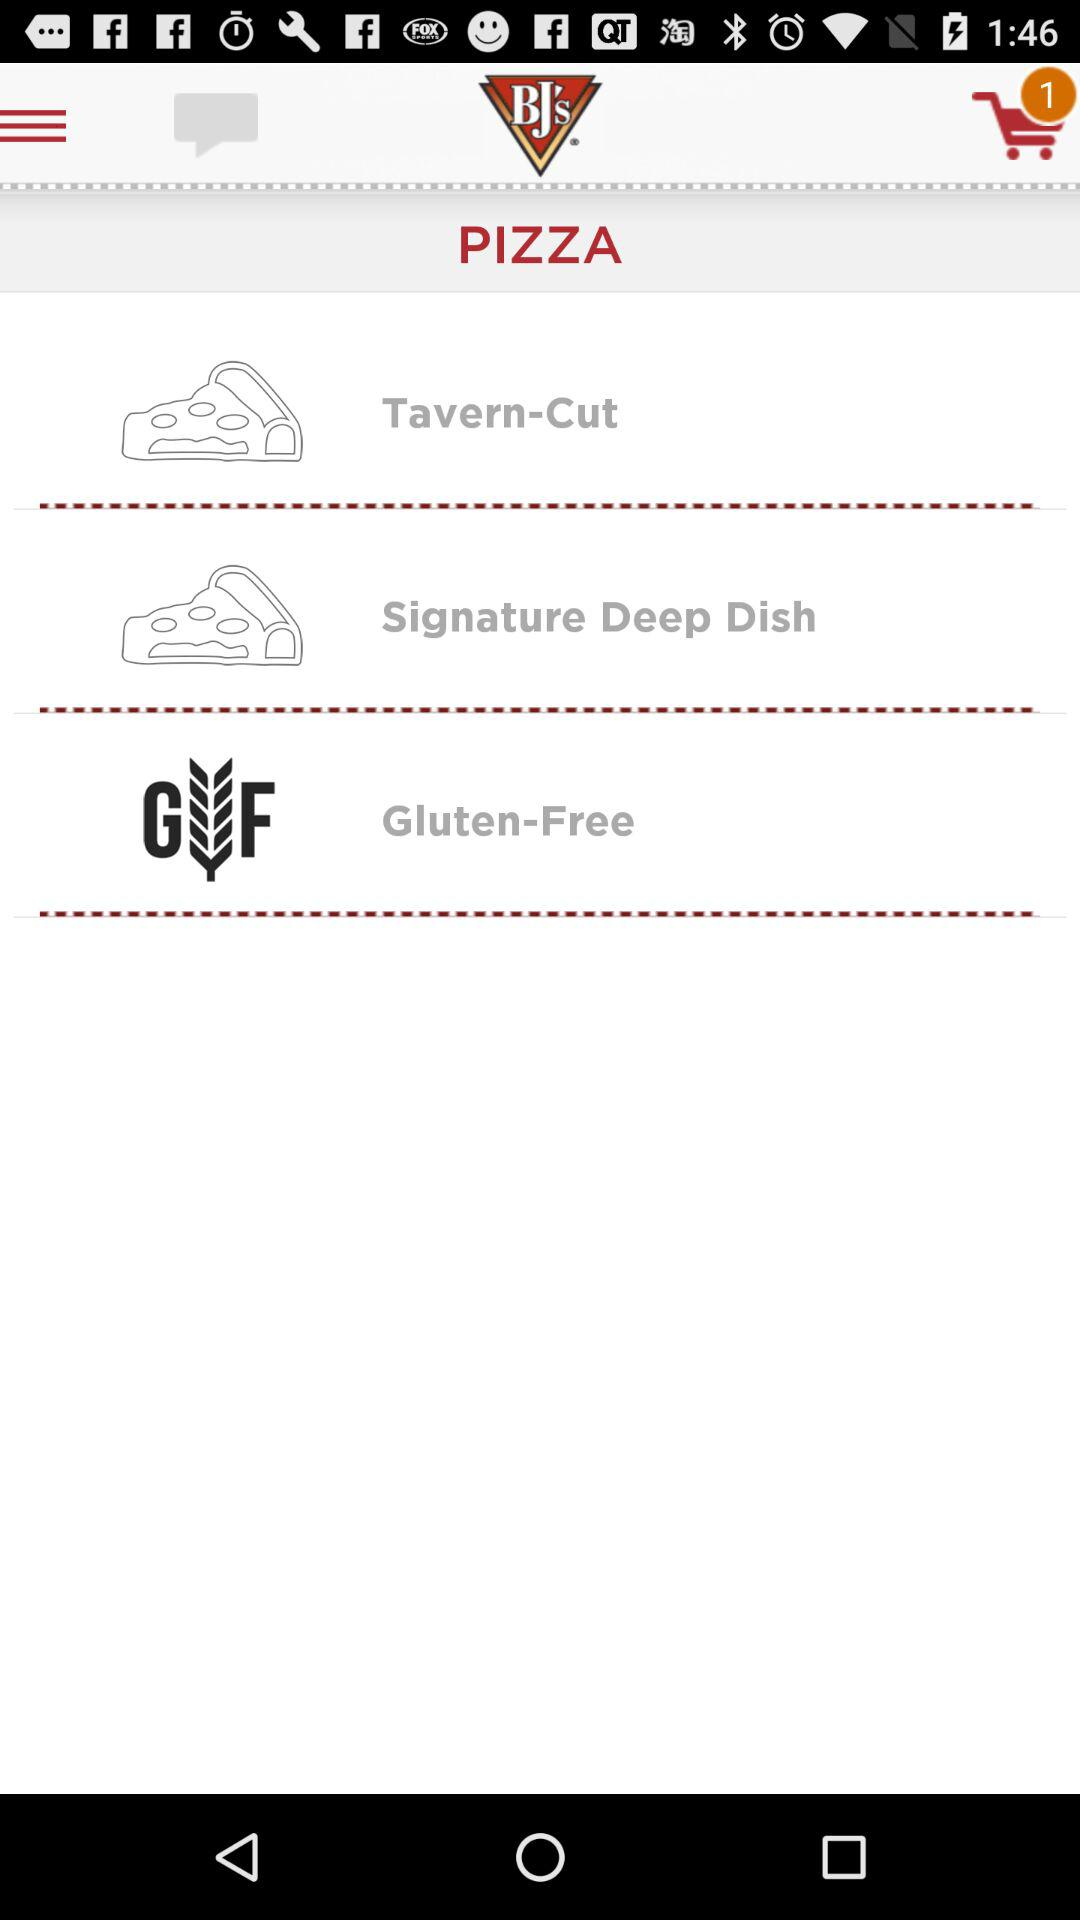How many pizza options are there?
Answer the question using a single word or phrase. 3 